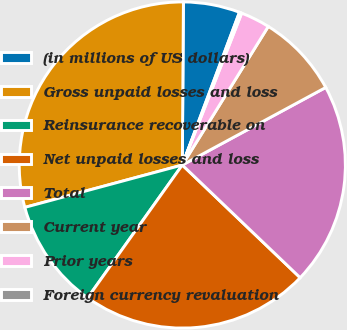<chart> <loc_0><loc_0><loc_500><loc_500><pie_chart><fcel>(in millions of US dollars)<fcel>Gross unpaid losses and loss<fcel>Reinsurance recoverable on<fcel>Net unpaid losses and loss<fcel>Total<fcel>Current year<fcel>Prior years<fcel>Foreign currency revaluation<nl><fcel>5.59%<fcel>29.29%<fcel>10.96%<fcel>22.71%<fcel>20.03%<fcel>8.27%<fcel>2.91%<fcel>0.23%<nl></chart> 